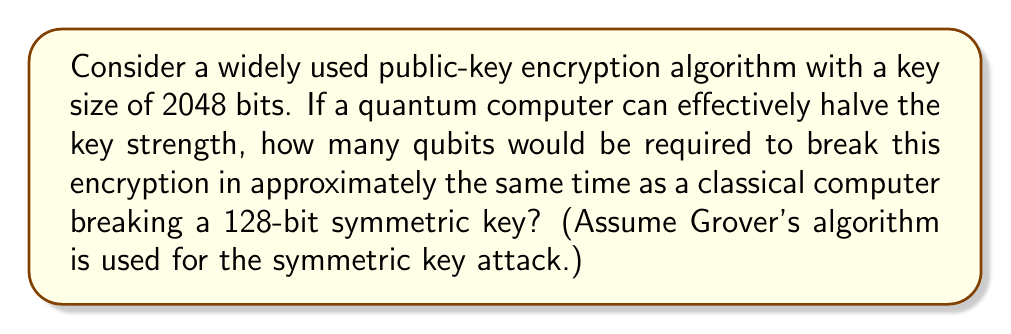Teach me how to tackle this problem. To solve this problem, we need to follow these steps:

1. Understand the impact of quantum computing on key strength:
   - Quantum computers can effectively halve the key strength of public-key algorithms.
   - For a 2048-bit key, the effective strength becomes 1024 bits.

2. Recall that Grover's algorithm provides a quadratic speedup for symmetric key attacks:
   - A 128-bit symmetric key has $2^{128}$ possible combinations.
   - With Grover's algorithm, this is reduced to $\sqrt{2^{128}} = 2^{64}$ operations.

3. Calculate the number of operations needed to break the weakened public-key:
   - $2^{1024}$ operations are required.

4. Determine the number of qubits needed:
   - The number of qubits is approximately equal to the number of bits in the key.
   - Therefore, we need 1024 qubits.

5. Verify the equivalence:
   - A quantum computer with 1024 qubits can perform $2^{1024}$ operations in roughly the same time as a classical computer performs $2^{64}$ operations (breaking a 128-bit symmetric key).

This analysis demonstrates the potential threat quantum computers pose to current encryption algorithms, highlighting the need for quantum-resistant cryptographic standards.
Answer: 1024 qubits 